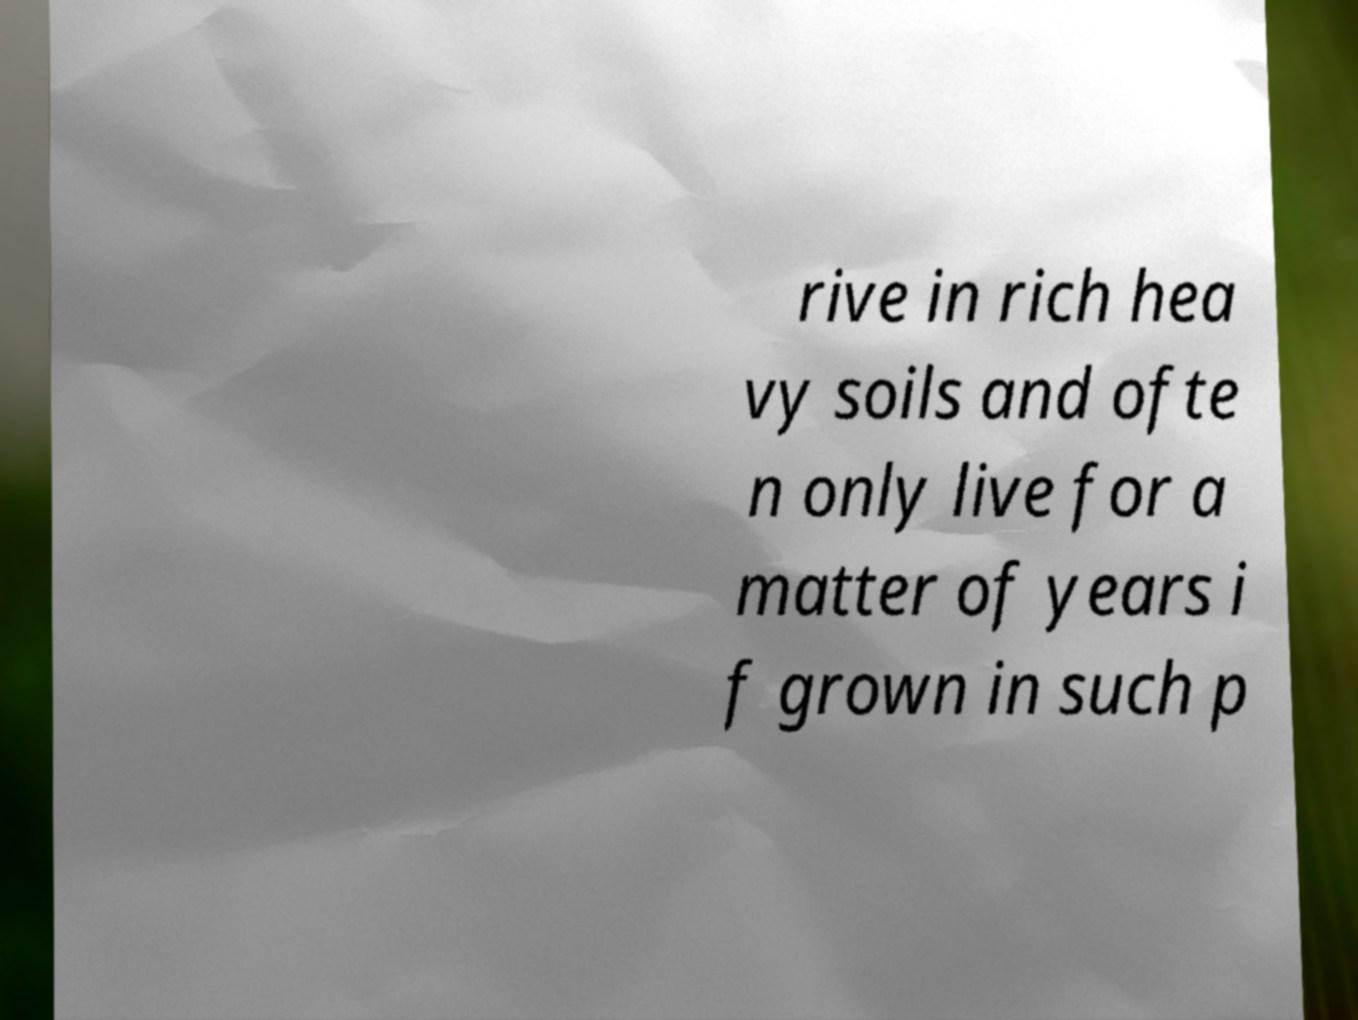Can you accurately transcribe the text from the provided image for me? rive in rich hea vy soils and ofte n only live for a matter of years i f grown in such p 